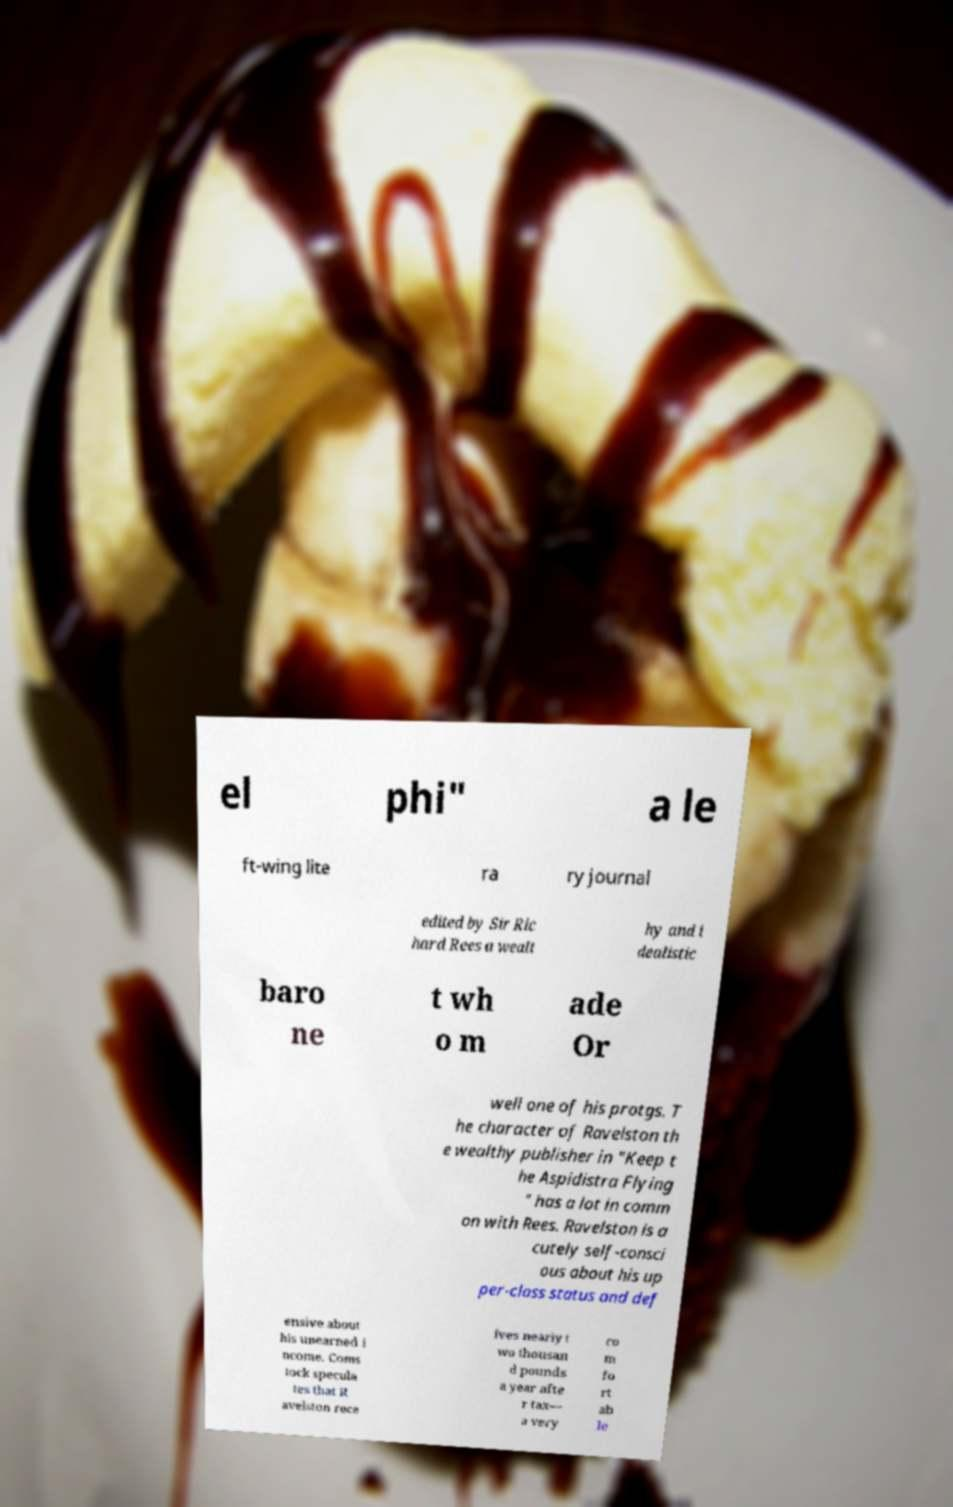Could you extract and type out the text from this image? el phi" a le ft-wing lite ra ry journal edited by Sir Ric hard Rees a wealt hy and i dealistic baro ne t wh o m ade Or well one of his protgs. T he character of Ravelston th e wealthy publisher in "Keep t he Aspidistra Flying " has a lot in comm on with Rees. Ravelston is a cutely self-consci ous about his up per-class status and def ensive about his unearned i ncome. Coms tock specula tes that R avelston rece ives nearly t wo thousan d pounds a year afte r tax— a very co m fo rt ab le 